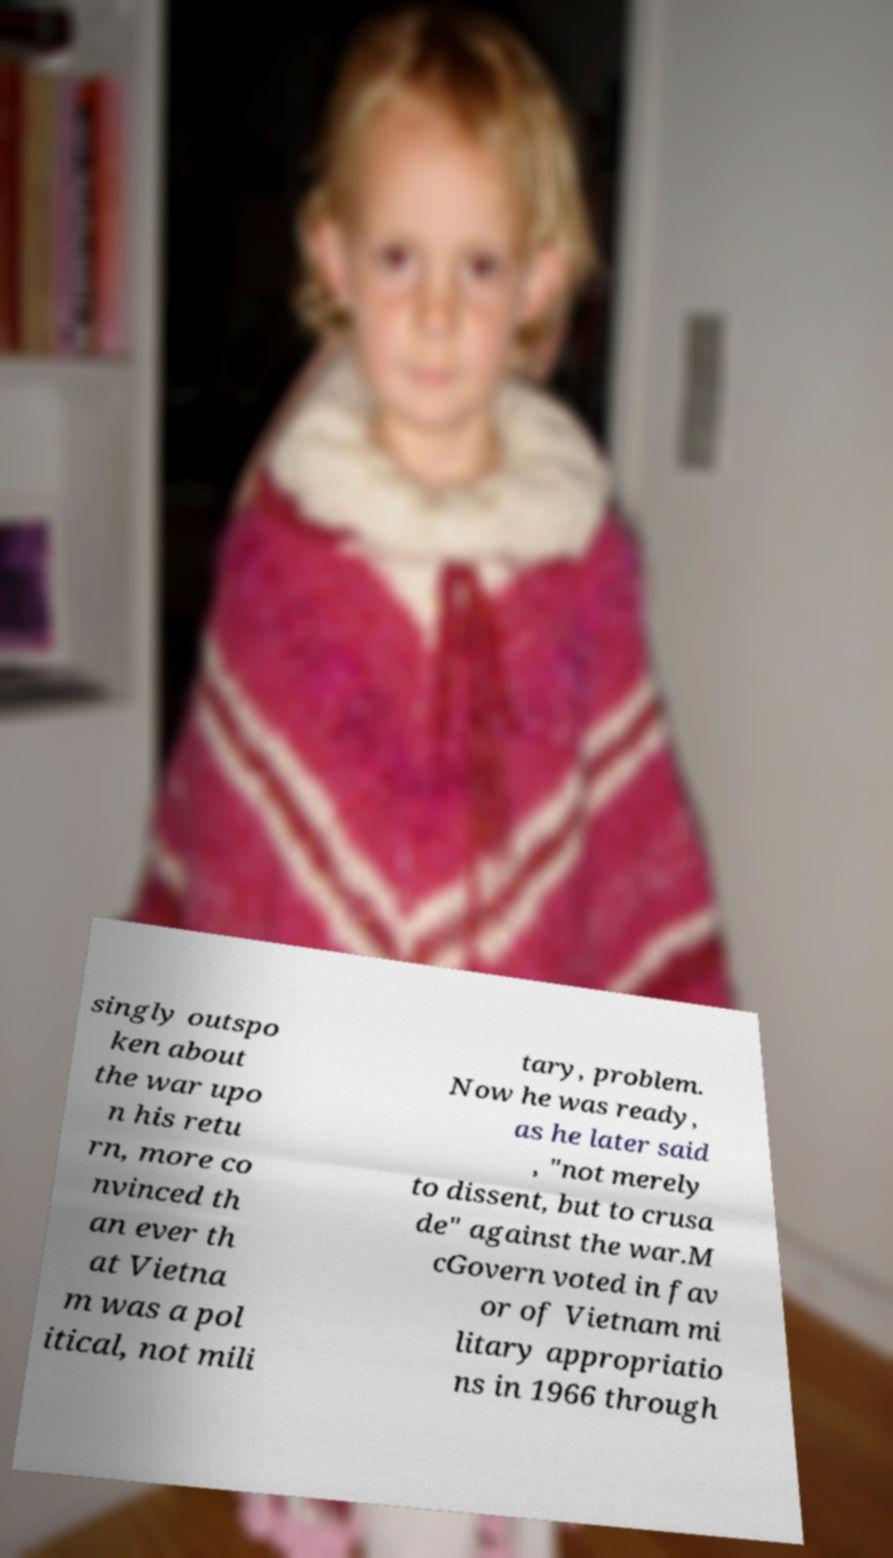Please read and relay the text visible in this image. What does it say? singly outspo ken about the war upo n his retu rn, more co nvinced th an ever th at Vietna m was a pol itical, not mili tary, problem. Now he was ready, as he later said , "not merely to dissent, but to crusa de" against the war.M cGovern voted in fav or of Vietnam mi litary appropriatio ns in 1966 through 